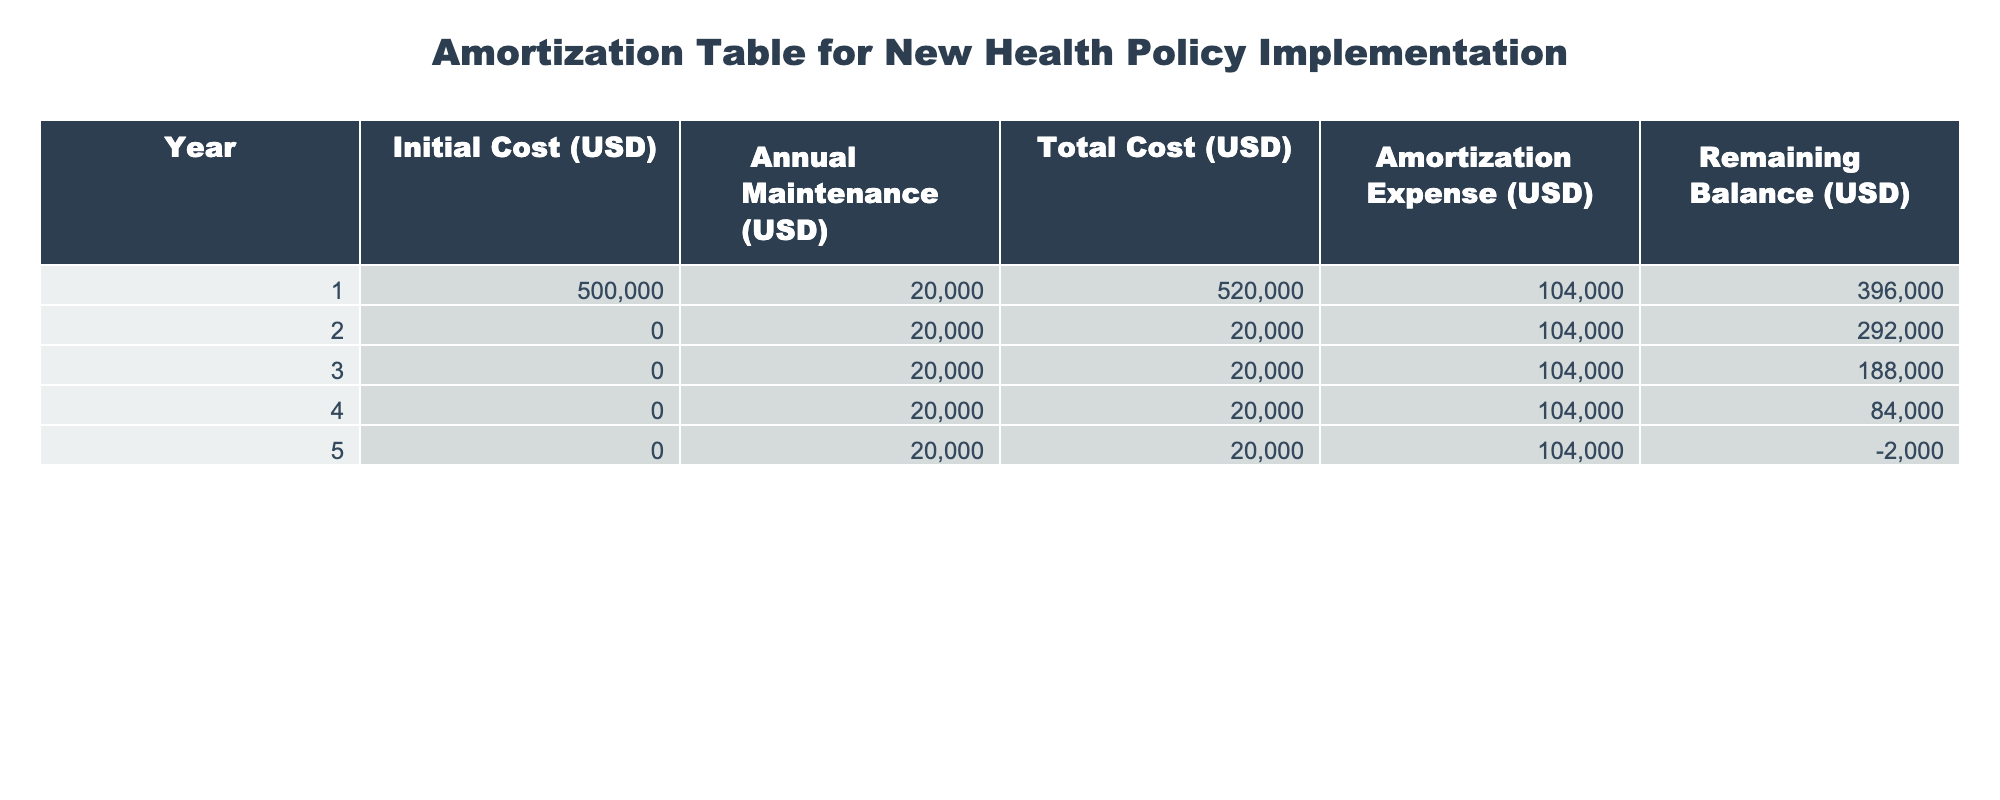What was the total cost during the first year of implementing the health policy? The total cost for the first year is provided in the table as 520000 USD.
Answer: 520000 USD How much is the remaining balance after the third year? The remaining balance after the third year is listed in the table as 188000 USD.
Answer: 188000 USD What is the total amortization expense over the entire period? The amortization expense for each year is consistently recorded as 104000 USD. Since there are 5 years, the total amortization expense is 104000 USD * 5 = 520000 USD.
Answer: 520000 USD Did the remaining balance ever become negative? Yes, according to the table, the remaining balance is shown as -2000 USD at the end of the fifth year.
Answer: Yes What is the average annual maintenance cost over the five years? The annual maintenance cost is consistently listed as 20000 USD for each year. Therefore, the average is 20000 USD since all values are the same.
Answer: 20000 USD How much did the total costs accumulate to by the end of year 4? The total cost for the first year is 520000 USD, and for the subsequent years (2-4), each has total costs of 20000 USD. Therefore, by the end of year 4, the accumulated total cost is 520000 USD + (20000 USD * 3) = 520000 USD + 60000 USD = 580000 USD.
Answer: 580000 USD Was the initial cost completely amortized by the end of year 5? Yes, by the end of year 5, the initial cost of 500000 USD is entirely accounted for in the amortization expenses totaling 520000 USD.
Answer: Yes What is the total maintenance cost incurred at the end of the entire period? The maintenance cost of 20000 USD occurs each year for 5 years, leading to a total maintenance cost of 20000 USD * 5 = 100000 USD at the end of the period.
Answer: 100000 USD What is the difference between the total cost in the first year and the total cost in the second year? The total cost in the first year is 520000 USD, while the total cost in the second year is 20000 USD. The difference is 520000 USD - 20000 USD = 500000 USD.
Answer: 500000 USD 